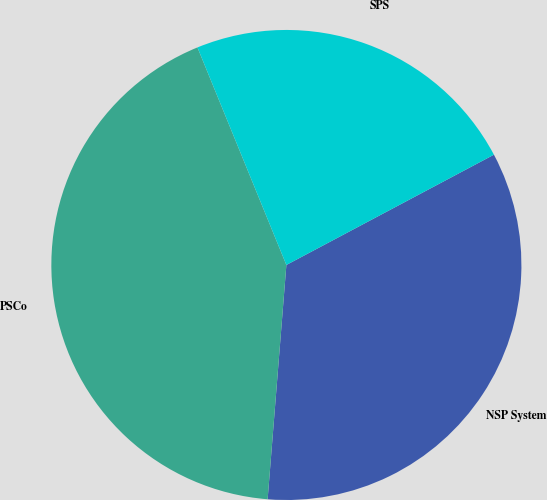Convert chart to OTSL. <chart><loc_0><loc_0><loc_500><loc_500><pie_chart><fcel>NSP System<fcel>PSCo<fcel>SPS<nl><fcel>34.04%<fcel>42.55%<fcel>23.4%<nl></chart> 